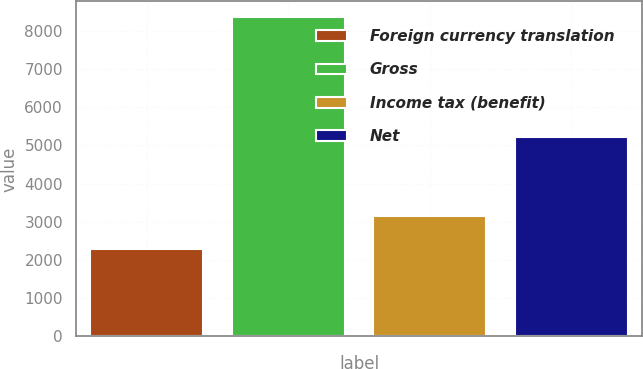<chart> <loc_0><loc_0><loc_500><loc_500><bar_chart><fcel>Foreign currency translation<fcel>Gross<fcel>Income tax (benefit)<fcel>Net<nl><fcel>2277<fcel>8346<fcel>3141<fcel>5205<nl></chart> 